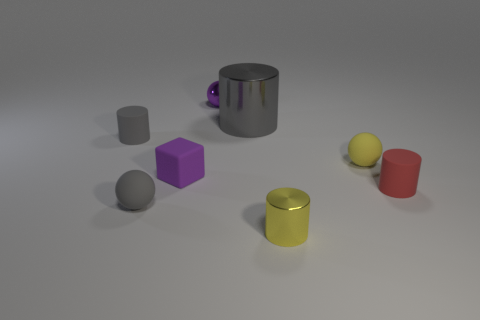Add 2 cyan rubber blocks. How many objects exist? 10 Subtract all cubes. How many objects are left? 7 Subtract 1 purple balls. How many objects are left? 7 Subtract all tiny gray metallic cylinders. Subtract all purple balls. How many objects are left? 7 Add 6 yellow shiny objects. How many yellow shiny objects are left? 7 Add 8 small blue metallic cubes. How many small blue metallic cubes exist? 8 